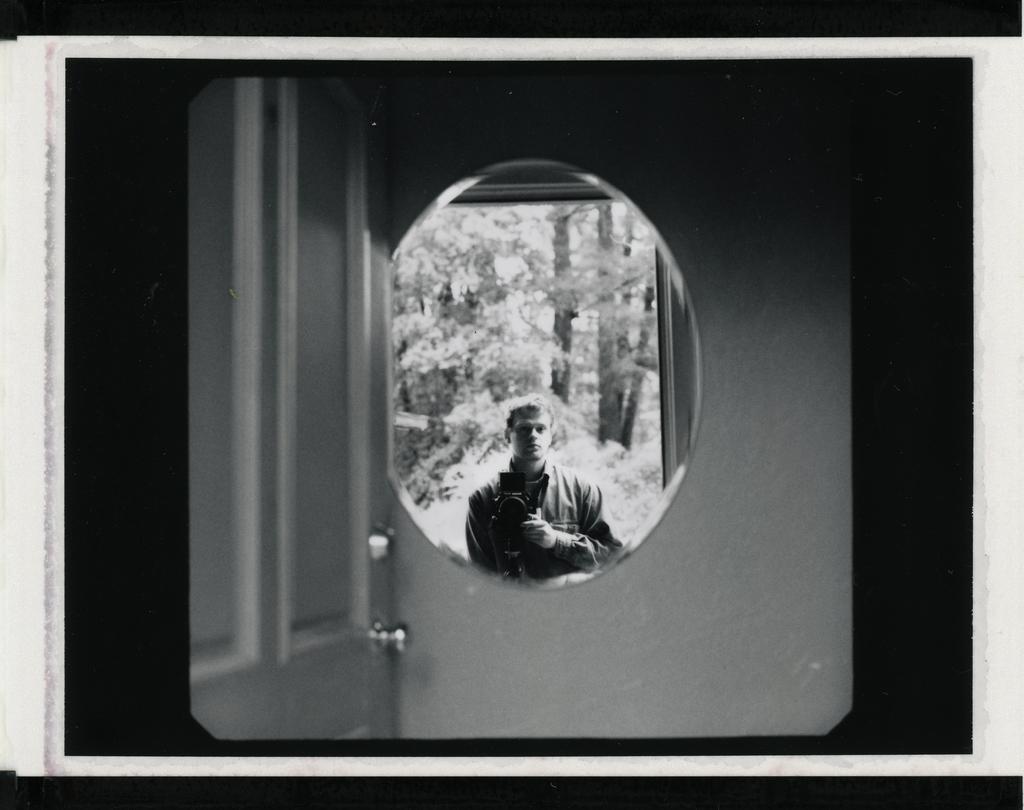How would you summarize this image in a sentence or two? In this image we can see the reflection of the person and trees on the mirror hanging on the wall, beside the mirror there is a door. 